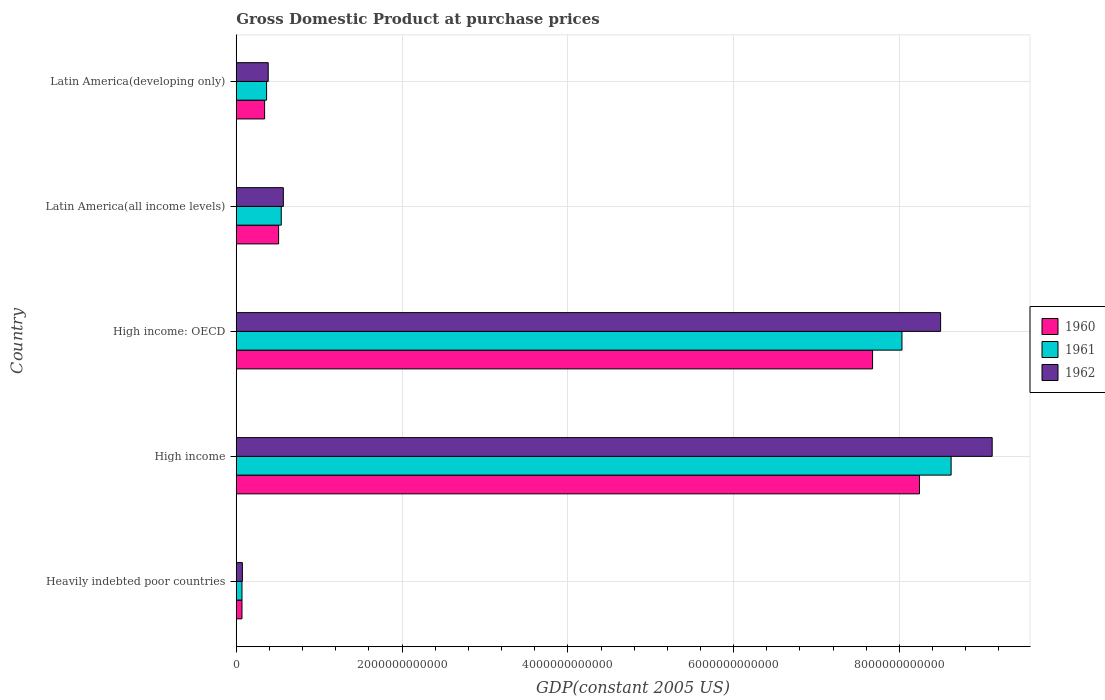Are the number of bars per tick equal to the number of legend labels?
Make the answer very short. Yes. Are the number of bars on each tick of the Y-axis equal?
Keep it short and to the point. Yes. How many bars are there on the 5th tick from the top?
Offer a very short reply. 3. What is the GDP at purchase prices in 1962 in High income: OECD?
Your answer should be very brief. 8.50e+12. Across all countries, what is the maximum GDP at purchase prices in 1960?
Offer a terse response. 8.24e+12. Across all countries, what is the minimum GDP at purchase prices in 1960?
Provide a succinct answer. 6.90e+1. In which country was the GDP at purchase prices in 1960 maximum?
Give a very brief answer. High income. In which country was the GDP at purchase prices in 1961 minimum?
Your answer should be compact. Heavily indebted poor countries. What is the total GDP at purchase prices in 1961 in the graph?
Offer a very short reply. 1.76e+13. What is the difference between the GDP at purchase prices in 1961 in High income: OECD and that in Latin America(all income levels)?
Offer a terse response. 7.49e+12. What is the difference between the GDP at purchase prices in 1961 in High income and the GDP at purchase prices in 1962 in Latin America(all income levels)?
Make the answer very short. 8.06e+12. What is the average GDP at purchase prices in 1960 per country?
Offer a terse response. 3.37e+12. What is the difference between the GDP at purchase prices in 1962 and GDP at purchase prices in 1961 in High income: OECD?
Ensure brevity in your answer.  4.66e+11. In how many countries, is the GDP at purchase prices in 1960 greater than 8000000000000 US$?
Offer a very short reply. 1. What is the ratio of the GDP at purchase prices in 1962 in Latin America(all income levels) to that in Latin America(developing only)?
Give a very brief answer. 1.47. Is the difference between the GDP at purchase prices in 1962 in High income and High income: OECD greater than the difference between the GDP at purchase prices in 1961 in High income and High income: OECD?
Provide a short and direct response. Yes. What is the difference between the highest and the second highest GDP at purchase prices in 1960?
Your answer should be very brief. 5.66e+11. What is the difference between the highest and the lowest GDP at purchase prices in 1960?
Provide a short and direct response. 8.17e+12. Is the sum of the GDP at purchase prices in 1960 in Heavily indebted poor countries and High income greater than the maximum GDP at purchase prices in 1962 across all countries?
Your answer should be compact. No. What does the 2nd bar from the top in Heavily indebted poor countries represents?
Provide a short and direct response. 1961. What does the 3rd bar from the bottom in High income represents?
Your answer should be very brief. 1962. How many bars are there?
Keep it short and to the point. 15. Are all the bars in the graph horizontal?
Give a very brief answer. Yes. How many countries are there in the graph?
Your answer should be compact. 5. What is the difference between two consecutive major ticks on the X-axis?
Keep it short and to the point. 2.00e+12. Does the graph contain grids?
Offer a very short reply. Yes. Where does the legend appear in the graph?
Your answer should be compact. Center right. How many legend labels are there?
Your response must be concise. 3. What is the title of the graph?
Keep it short and to the point. Gross Domestic Product at purchase prices. Does "2012" appear as one of the legend labels in the graph?
Your answer should be compact. No. What is the label or title of the X-axis?
Provide a short and direct response. GDP(constant 2005 US). What is the label or title of the Y-axis?
Keep it short and to the point. Country. What is the GDP(constant 2005 US) in 1960 in Heavily indebted poor countries?
Offer a very short reply. 6.90e+1. What is the GDP(constant 2005 US) of 1961 in Heavily indebted poor countries?
Provide a short and direct response. 6.91e+1. What is the GDP(constant 2005 US) in 1962 in Heavily indebted poor countries?
Give a very brief answer. 7.41e+1. What is the GDP(constant 2005 US) in 1960 in High income?
Ensure brevity in your answer.  8.24e+12. What is the GDP(constant 2005 US) of 1961 in High income?
Your answer should be compact. 8.62e+12. What is the GDP(constant 2005 US) of 1962 in High income?
Make the answer very short. 9.12e+12. What is the GDP(constant 2005 US) in 1960 in High income: OECD?
Make the answer very short. 7.68e+12. What is the GDP(constant 2005 US) in 1961 in High income: OECD?
Keep it short and to the point. 8.03e+12. What is the GDP(constant 2005 US) in 1962 in High income: OECD?
Your answer should be very brief. 8.50e+12. What is the GDP(constant 2005 US) of 1960 in Latin America(all income levels)?
Give a very brief answer. 5.11e+11. What is the GDP(constant 2005 US) of 1961 in Latin America(all income levels)?
Keep it short and to the point. 5.43e+11. What is the GDP(constant 2005 US) in 1962 in Latin America(all income levels)?
Your answer should be very brief. 5.68e+11. What is the GDP(constant 2005 US) in 1960 in Latin America(developing only)?
Offer a terse response. 3.42e+11. What is the GDP(constant 2005 US) in 1961 in Latin America(developing only)?
Your response must be concise. 3.66e+11. What is the GDP(constant 2005 US) of 1962 in Latin America(developing only)?
Offer a very short reply. 3.86e+11. Across all countries, what is the maximum GDP(constant 2005 US) of 1960?
Make the answer very short. 8.24e+12. Across all countries, what is the maximum GDP(constant 2005 US) in 1961?
Offer a terse response. 8.62e+12. Across all countries, what is the maximum GDP(constant 2005 US) of 1962?
Provide a short and direct response. 9.12e+12. Across all countries, what is the minimum GDP(constant 2005 US) in 1960?
Your answer should be compact. 6.90e+1. Across all countries, what is the minimum GDP(constant 2005 US) of 1961?
Your answer should be compact. 6.91e+1. Across all countries, what is the minimum GDP(constant 2005 US) in 1962?
Provide a succinct answer. 7.41e+1. What is the total GDP(constant 2005 US) of 1960 in the graph?
Your response must be concise. 1.68e+13. What is the total GDP(constant 2005 US) in 1961 in the graph?
Your response must be concise. 1.76e+13. What is the total GDP(constant 2005 US) of 1962 in the graph?
Provide a succinct answer. 1.86e+13. What is the difference between the GDP(constant 2005 US) of 1960 in Heavily indebted poor countries and that in High income?
Provide a short and direct response. -8.17e+12. What is the difference between the GDP(constant 2005 US) in 1961 in Heavily indebted poor countries and that in High income?
Your response must be concise. -8.55e+12. What is the difference between the GDP(constant 2005 US) in 1962 in Heavily indebted poor countries and that in High income?
Offer a terse response. -9.04e+12. What is the difference between the GDP(constant 2005 US) of 1960 in Heavily indebted poor countries and that in High income: OECD?
Your answer should be very brief. -7.61e+12. What is the difference between the GDP(constant 2005 US) in 1961 in Heavily indebted poor countries and that in High income: OECD?
Offer a very short reply. -7.96e+12. What is the difference between the GDP(constant 2005 US) of 1962 in Heavily indebted poor countries and that in High income: OECD?
Your response must be concise. -8.42e+12. What is the difference between the GDP(constant 2005 US) in 1960 in Heavily indebted poor countries and that in Latin America(all income levels)?
Provide a succinct answer. -4.42e+11. What is the difference between the GDP(constant 2005 US) of 1961 in Heavily indebted poor countries and that in Latin America(all income levels)?
Provide a short and direct response. -4.74e+11. What is the difference between the GDP(constant 2005 US) in 1962 in Heavily indebted poor countries and that in Latin America(all income levels)?
Offer a very short reply. -4.94e+11. What is the difference between the GDP(constant 2005 US) in 1960 in Heavily indebted poor countries and that in Latin America(developing only)?
Provide a short and direct response. -2.73e+11. What is the difference between the GDP(constant 2005 US) of 1961 in Heavily indebted poor countries and that in Latin America(developing only)?
Ensure brevity in your answer.  -2.97e+11. What is the difference between the GDP(constant 2005 US) of 1962 in Heavily indebted poor countries and that in Latin America(developing only)?
Provide a succinct answer. -3.11e+11. What is the difference between the GDP(constant 2005 US) of 1960 in High income and that in High income: OECD?
Provide a short and direct response. 5.66e+11. What is the difference between the GDP(constant 2005 US) of 1961 in High income and that in High income: OECD?
Keep it short and to the point. 5.93e+11. What is the difference between the GDP(constant 2005 US) of 1962 in High income and that in High income: OECD?
Provide a succinct answer. 6.22e+11. What is the difference between the GDP(constant 2005 US) in 1960 in High income and that in Latin America(all income levels)?
Your response must be concise. 7.73e+12. What is the difference between the GDP(constant 2005 US) of 1961 in High income and that in Latin America(all income levels)?
Offer a very short reply. 8.08e+12. What is the difference between the GDP(constant 2005 US) of 1962 in High income and that in Latin America(all income levels)?
Offer a very short reply. 8.55e+12. What is the difference between the GDP(constant 2005 US) in 1960 in High income and that in Latin America(developing only)?
Provide a succinct answer. 7.90e+12. What is the difference between the GDP(constant 2005 US) in 1961 in High income and that in Latin America(developing only)?
Offer a terse response. 8.26e+12. What is the difference between the GDP(constant 2005 US) of 1962 in High income and that in Latin America(developing only)?
Make the answer very short. 8.73e+12. What is the difference between the GDP(constant 2005 US) of 1960 in High income: OECD and that in Latin America(all income levels)?
Offer a very short reply. 7.16e+12. What is the difference between the GDP(constant 2005 US) of 1961 in High income: OECD and that in Latin America(all income levels)?
Provide a succinct answer. 7.49e+12. What is the difference between the GDP(constant 2005 US) in 1962 in High income: OECD and that in Latin America(all income levels)?
Give a very brief answer. 7.93e+12. What is the difference between the GDP(constant 2005 US) of 1960 in High income: OECD and that in Latin America(developing only)?
Provide a short and direct response. 7.33e+12. What is the difference between the GDP(constant 2005 US) in 1961 in High income: OECD and that in Latin America(developing only)?
Your answer should be very brief. 7.66e+12. What is the difference between the GDP(constant 2005 US) in 1962 in High income: OECD and that in Latin America(developing only)?
Your answer should be compact. 8.11e+12. What is the difference between the GDP(constant 2005 US) in 1960 in Latin America(all income levels) and that in Latin America(developing only)?
Offer a terse response. 1.69e+11. What is the difference between the GDP(constant 2005 US) in 1961 in Latin America(all income levels) and that in Latin America(developing only)?
Your answer should be very brief. 1.77e+11. What is the difference between the GDP(constant 2005 US) of 1962 in Latin America(all income levels) and that in Latin America(developing only)?
Make the answer very short. 1.83e+11. What is the difference between the GDP(constant 2005 US) of 1960 in Heavily indebted poor countries and the GDP(constant 2005 US) of 1961 in High income?
Give a very brief answer. -8.55e+12. What is the difference between the GDP(constant 2005 US) of 1960 in Heavily indebted poor countries and the GDP(constant 2005 US) of 1962 in High income?
Ensure brevity in your answer.  -9.05e+12. What is the difference between the GDP(constant 2005 US) in 1961 in Heavily indebted poor countries and the GDP(constant 2005 US) in 1962 in High income?
Your response must be concise. -9.05e+12. What is the difference between the GDP(constant 2005 US) in 1960 in Heavily indebted poor countries and the GDP(constant 2005 US) in 1961 in High income: OECD?
Give a very brief answer. -7.96e+12. What is the difference between the GDP(constant 2005 US) of 1960 in Heavily indebted poor countries and the GDP(constant 2005 US) of 1962 in High income: OECD?
Give a very brief answer. -8.43e+12. What is the difference between the GDP(constant 2005 US) in 1961 in Heavily indebted poor countries and the GDP(constant 2005 US) in 1962 in High income: OECD?
Give a very brief answer. -8.43e+12. What is the difference between the GDP(constant 2005 US) of 1960 in Heavily indebted poor countries and the GDP(constant 2005 US) of 1961 in Latin America(all income levels)?
Offer a very short reply. -4.74e+11. What is the difference between the GDP(constant 2005 US) in 1960 in Heavily indebted poor countries and the GDP(constant 2005 US) in 1962 in Latin America(all income levels)?
Your answer should be compact. -4.99e+11. What is the difference between the GDP(constant 2005 US) in 1961 in Heavily indebted poor countries and the GDP(constant 2005 US) in 1962 in Latin America(all income levels)?
Offer a very short reply. -4.99e+11. What is the difference between the GDP(constant 2005 US) of 1960 in Heavily indebted poor countries and the GDP(constant 2005 US) of 1961 in Latin America(developing only)?
Ensure brevity in your answer.  -2.97e+11. What is the difference between the GDP(constant 2005 US) in 1960 in Heavily indebted poor countries and the GDP(constant 2005 US) in 1962 in Latin America(developing only)?
Offer a very short reply. -3.16e+11. What is the difference between the GDP(constant 2005 US) in 1961 in Heavily indebted poor countries and the GDP(constant 2005 US) in 1962 in Latin America(developing only)?
Offer a terse response. -3.16e+11. What is the difference between the GDP(constant 2005 US) in 1960 in High income and the GDP(constant 2005 US) in 1961 in High income: OECD?
Give a very brief answer. 2.11e+11. What is the difference between the GDP(constant 2005 US) of 1960 in High income and the GDP(constant 2005 US) of 1962 in High income: OECD?
Offer a very short reply. -2.55e+11. What is the difference between the GDP(constant 2005 US) in 1961 in High income and the GDP(constant 2005 US) in 1962 in High income: OECD?
Provide a short and direct response. 1.27e+11. What is the difference between the GDP(constant 2005 US) in 1960 in High income and the GDP(constant 2005 US) in 1961 in Latin America(all income levels)?
Offer a very short reply. 7.70e+12. What is the difference between the GDP(constant 2005 US) in 1960 in High income and the GDP(constant 2005 US) in 1962 in Latin America(all income levels)?
Offer a very short reply. 7.67e+12. What is the difference between the GDP(constant 2005 US) of 1961 in High income and the GDP(constant 2005 US) of 1962 in Latin America(all income levels)?
Keep it short and to the point. 8.06e+12. What is the difference between the GDP(constant 2005 US) of 1960 in High income and the GDP(constant 2005 US) of 1961 in Latin America(developing only)?
Your answer should be compact. 7.88e+12. What is the difference between the GDP(constant 2005 US) in 1960 in High income and the GDP(constant 2005 US) in 1962 in Latin America(developing only)?
Make the answer very short. 7.86e+12. What is the difference between the GDP(constant 2005 US) of 1961 in High income and the GDP(constant 2005 US) of 1962 in Latin America(developing only)?
Provide a succinct answer. 8.24e+12. What is the difference between the GDP(constant 2005 US) in 1960 in High income: OECD and the GDP(constant 2005 US) in 1961 in Latin America(all income levels)?
Make the answer very short. 7.13e+12. What is the difference between the GDP(constant 2005 US) of 1960 in High income: OECD and the GDP(constant 2005 US) of 1962 in Latin America(all income levels)?
Provide a short and direct response. 7.11e+12. What is the difference between the GDP(constant 2005 US) of 1961 in High income: OECD and the GDP(constant 2005 US) of 1962 in Latin America(all income levels)?
Provide a succinct answer. 7.46e+12. What is the difference between the GDP(constant 2005 US) of 1960 in High income: OECD and the GDP(constant 2005 US) of 1961 in Latin America(developing only)?
Make the answer very short. 7.31e+12. What is the difference between the GDP(constant 2005 US) of 1960 in High income: OECD and the GDP(constant 2005 US) of 1962 in Latin America(developing only)?
Provide a short and direct response. 7.29e+12. What is the difference between the GDP(constant 2005 US) of 1961 in High income: OECD and the GDP(constant 2005 US) of 1962 in Latin America(developing only)?
Keep it short and to the point. 7.64e+12. What is the difference between the GDP(constant 2005 US) in 1960 in Latin America(all income levels) and the GDP(constant 2005 US) in 1961 in Latin America(developing only)?
Make the answer very short. 1.45e+11. What is the difference between the GDP(constant 2005 US) in 1960 in Latin America(all income levels) and the GDP(constant 2005 US) in 1962 in Latin America(developing only)?
Offer a terse response. 1.25e+11. What is the difference between the GDP(constant 2005 US) of 1961 in Latin America(all income levels) and the GDP(constant 2005 US) of 1962 in Latin America(developing only)?
Provide a short and direct response. 1.57e+11. What is the average GDP(constant 2005 US) of 1960 per country?
Provide a succinct answer. 3.37e+12. What is the average GDP(constant 2005 US) of 1961 per country?
Give a very brief answer. 3.53e+12. What is the average GDP(constant 2005 US) in 1962 per country?
Offer a very short reply. 3.73e+12. What is the difference between the GDP(constant 2005 US) in 1960 and GDP(constant 2005 US) in 1961 in Heavily indebted poor countries?
Your answer should be compact. -9.28e+07. What is the difference between the GDP(constant 2005 US) of 1960 and GDP(constant 2005 US) of 1962 in Heavily indebted poor countries?
Make the answer very short. -5.08e+09. What is the difference between the GDP(constant 2005 US) in 1961 and GDP(constant 2005 US) in 1962 in Heavily indebted poor countries?
Keep it short and to the point. -4.99e+09. What is the difference between the GDP(constant 2005 US) of 1960 and GDP(constant 2005 US) of 1961 in High income?
Your answer should be very brief. -3.82e+11. What is the difference between the GDP(constant 2005 US) of 1960 and GDP(constant 2005 US) of 1962 in High income?
Offer a very short reply. -8.77e+11. What is the difference between the GDP(constant 2005 US) in 1961 and GDP(constant 2005 US) in 1962 in High income?
Give a very brief answer. -4.95e+11. What is the difference between the GDP(constant 2005 US) of 1960 and GDP(constant 2005 US) of 1961 in High income: OECD?
Your answer should be very brief. -3.55e+11. What is the difference between the GDP(constant 2005 US) in 1960 and GDP(constant 2005 US) in 1962 in High income: OECD?
Ensure brevity in your answer.  -8.21e+11. What is the difference between the GDP(constant 2005 US) of 1961 and GDP(constant 2005 US) of 1962 in High income: OECD?
Provide a succinct answer. -4.66e+11. What is the difference between the GDP(constant 2005 US) in 1960 and GDP(constant 2005 US) in 1961 in Latin America(all income levels)?
Keep it short and to the point. -3.20e+1. What is the difference between the GDP(constant 2005 US) of 1960 and GDP(constant 2005 US) of 1962 in Latin America(all income levels)?
Provide a short and direct response. -5.72e+1. What is the difference between the GDP(constant 2005 US) of 1961 and GDP(constant 2005 US) of 1962 in Latin America(all income levels)?
Your answer should be very brief. -2.51e+1. What is the difference between the GDP(constant 2005 US) of 1960 and GDP(constant 2005 US) of 1961 in Latin America(developing only)?
Your answer should be compact. -2.39e+1. What is the difference between the GDP(constant 2005 US) in 1960 and GDP(constant 2005 US) in 1962 in Latin America(developing only)?
Ensure brevity in your answer.  -4.35e+1. What is the difference between the GDP(constant 2005 US) of 1961 and GDP(constant 2005 US) of 1962 in Latin America(developing only)?
Your response must be concise. -1.96e+1. What is the ratio of the GDP(constant 2005 US) in 1960 in Heavily indebted poor countries to that in High income?
Your answer should be compact. 0.01. What is the ratio of the GDP(constant 2005 US) in 1961 in Heavily indebted poor countries to that in High income?
Your response must be concise. 0.01. What is the ratio of the GDP(constant 2005 US) in 1962 in Heavily indebted poor countries to that in High income?
Make the answer very short. 0.01. What is the ratio of the GDP(constant 2005 US) in 1960 in Heavily indebted poor countries to that in High income: OECD?
Provide a short and direct response. 0.01. What is the ratio of the GDP(constant 2005 US) of 1961 in Heavily indebted poor countries to that in High income: OECD?
Your answer should be compact. 0.01. What is the ratio of the GDP(constant 2005 US) in 1962 in Heavily indebted poor countries to that in High income: OECD?
Ensure brevity in your answer.  0.01. What is the ratio of the GDP(constant 2005 US) of 1960 in Heavily indebted poor countries to that in Latin America(all income levels)?
Your answer should be compact. 0.14. What is the ratio of the GDP(constant 2005 US) of 1961 in Heavily indebted poor countries to that in Latin America(all income levels)?
Provide a succinct answer. 0.13. What is the ratio of the GDP(constant 2005 US) of 1962 in Heavily indebted poor countries to that in Latin America(all income levels)?
Ensure brevity in your answer.  0.13. What is the ratio of the GDP(constant 2005 US) in 1960 in Heavily indebted poor countries to that in Latin America(developing only)?
Provide a succinct answer. 0.2. What is the ratio of the GDP(constant 2005 US) in 1961 in Heavily indebted poor countries to that in Latin America(developing only)?
Your answer should be compact. 0.19. What is the ratio of the GDP(constant 2005 US) in 1962 in Heavily indebted poor countries to that in Latin America(developing only)?
Provide a short and direct response. 0.19. What is the ratio of the GDP(constant 2005 US) of 1960 in High income to that in High income: OECD?
Offer a terse response. 1.07. What is the ratio of the GDP(constant 2005 US) of 1961 in High income to that in High income: OECD?
Provide a succinct answer. 1.07. What is the ratio of the GDP(constant 2005 US) of 1962 in High income to that in High income: OECD?
Ensure brevity in your answer.  1.07. What is the ratio of the GDP(constant 2005 US) of 1960 in High income to that in Latin America(all income levels)?
Your response must be concise. 16.13. What is the ratio of the GDP(constant 2005 US) in 1961 in High income to that in Latin America(all income levels)?
Your answer should be compact. 15.88. What is the ratio of the GDP(constant 2005 US) of 1962 in High income to that in Latin America(all income levels)?
Offer a terse response. 16.05. What is the ratio of the GDP(constant 2005 US) of 1960 in High income to that in Latin America(developing only)?
Your response must be concise. 24.1. What is the ratio of the GDP(constant 2005 US) of 1961 in High income to that in Latin America(developing only)?
Your answer should be compact. 23.57. What is the ratio of the GDP(constant 2005 US) of 1962 in High income to that in Latin America(developing only)?
Make the answer very short. 23.65. What is the ratio of the GDP(constant 2005 US) in 1960 in High income: OECD to that in Latin America(all income levels)?
Your answer should be compact. 15.02. What is the ratio of the GDP(constant 2005 US) of 1961 in High income: OECD to that in Latin America(all income levels)?
Your response must be concise. 14.79. What is the ratio of the GDP(constant 2005 US) of 1962 in High income: OECD to that in Latin America(all income levels)?
Ensure brevity in your answer.  14.96. What is the ratio of the GDP(constant 2005 US) in 1960 in High income: OECD to that in Latin America(developing only)?
Provide a short and direct response. 22.44. What is the ratio of the GDP(constant 2005 US) of 1961 in High income: OECD to that in Latin America(developing only)?
Make the answer very short. 21.95. What is the ratio of the GDP(constant 2005 US) of 1962 in High income: OECD to that in Latin America(developing only)?
Make the answer very short. 22.04. What is the ratio of the GDP(constant 2005 US) in 1960 in Latin America(all income levels) to that in Latin America(developing only)?
Your answer should be compact. 1.49. What is the ratio of the GDP(constant 2005 US) in 1961 in Latin America(all income levels) to that in Latin America(developing only)?
Provide a short and direct response. 1.48. What is the ratio of the GDP(constant 2005 US) of 1962 in Latin America(all income levels) to that in Latin America(developing only)?
Give a very brief answer. 1.47. What is the difference between the highest and the second highest GDP(constant 2005 US) in 1960?
Your response must be concise. 5.66e+11. What is the difference between the highest and the second highest GDP(constant 2005 US) of 1961?
Provide a short and direct response. 5.93e+11. What is the difference between the highest and the second highest GDP(constant 2005 US) of 1962?
Keep it short and to the point. 6.22e+11. What is the difference between the highest and the lowest GDP(constant 2005 US) of 1960?
Your response must be concise. 8.17e+12. What is the difference between the highest and the lowest GDP(constant 2005 US) in 1961?
Provide a succinct answer. 8.55e+12. What is the difference between the highest and the lowest GDP(constant 2005 US) in 1962?
Offer a terse response. 9.04e+12. 